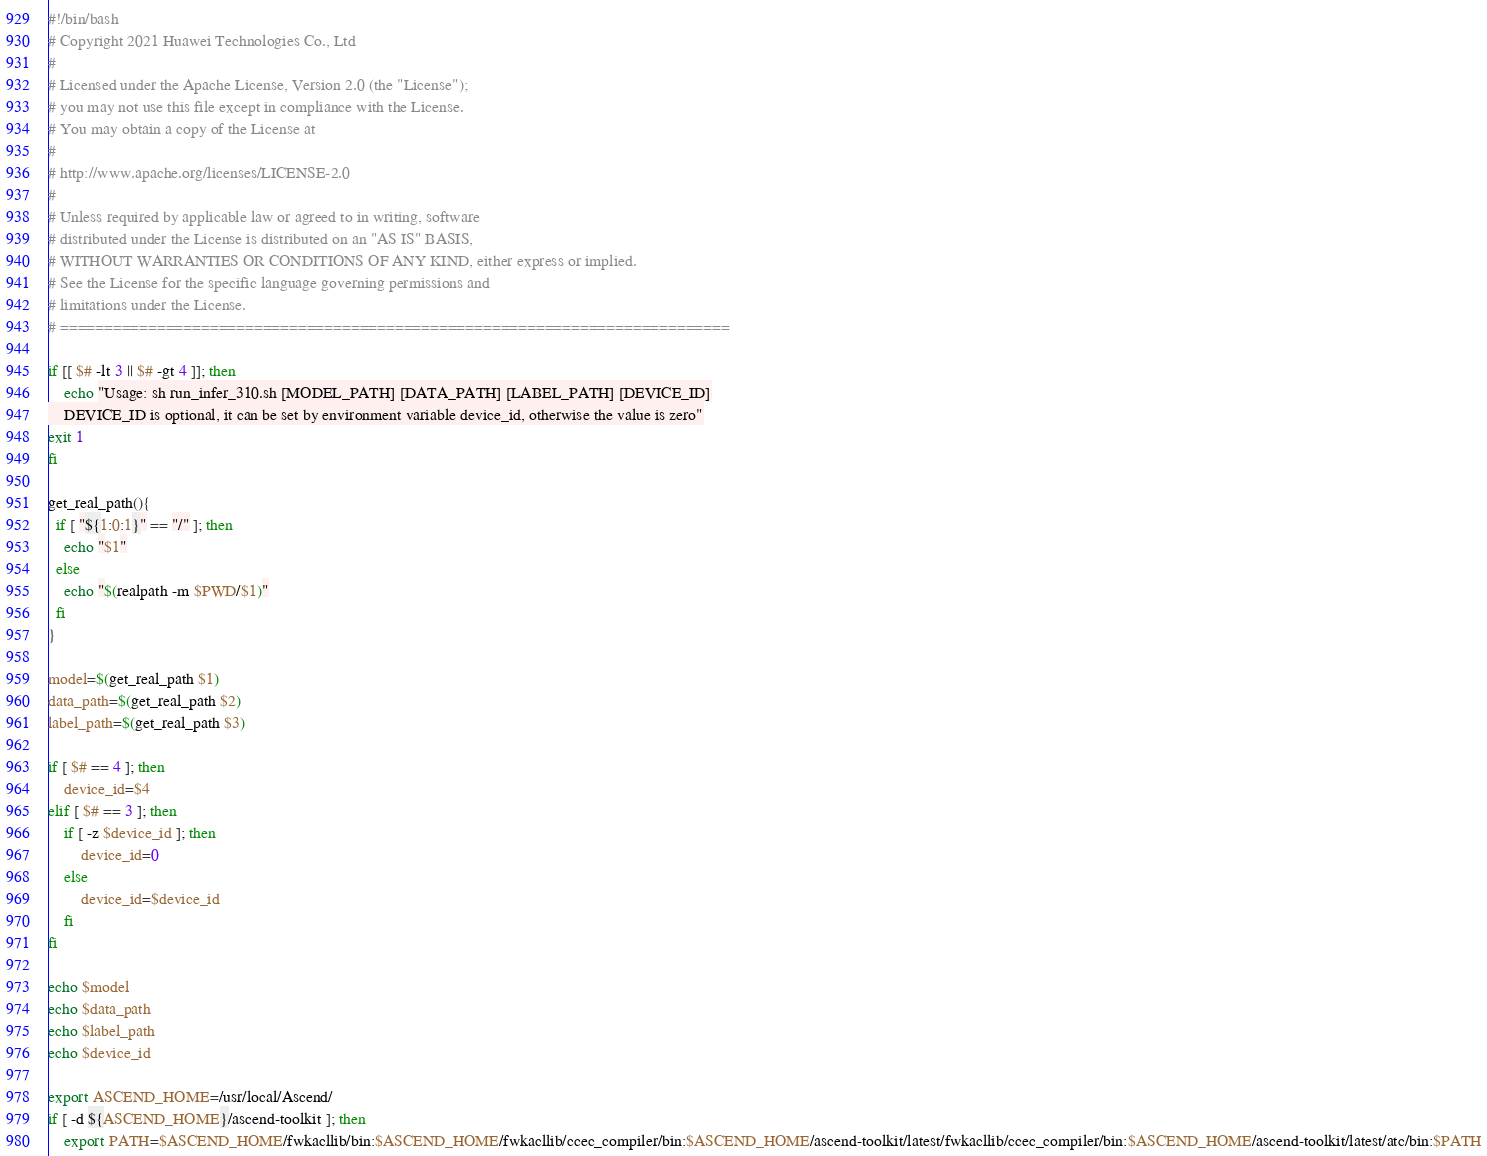Convert code to text. <code><loc_0><loc_0><loc_500><loc_500><_Bash_>#!/bin/bash
# Copyright 2021 Huawei Technologies Co., Ltd
#
# Licensed under the Apache License, Version 2.0 (the "License");
# you may not use this file except in compliance with the License.
# You may obtain a copy of the License at
#
# http://www.apache.org/licenses/LICENSE-2.0
#
# Unless required by applicable law or agreed to in writing, software
# distributed under the License is distributed on an "AS IS" BASIS,
# WITHOUT WARRANTIES OR CONDITIONS OF ANY KIND, either express or implied.
# See the License for the specific language governing permissions and
# limitations under the License.
# ============================================================================

if [[ $# -lt 3 || $# -gt 4 ]]; then 
    echo "Usage: sh run_infer_310.sh [MODEL_PATH] [DATA_PATH] [LABEL_PATH] [DEVICE_ID]
    DEVICE_ID is optional, it can be set by environment variable device_id, otherwise the value is zero"
exit 1
fi

get_real_path(){
  if [ "${1:0:1}" == "/" ]; then
    echo "$1"
  else
    echo "$(realpath -m $PWD/$1)"
  fi
}

model=$(get_real_path $1)
data_path=$(get_real_path $2)
label_path=$(get_real_path $3)

if [ $# == 4 ]; then
    device_id=$4
elif [ $# == 3 ]; then
    if [ -z $device_id ]; then
        device_id=0
    else
        device_id=$device_id
    fi
fi

echo $model
echo $data_path
echo $label_path
echo $device_id

export ASCEND_HOME=/usr/local/Ascend/
if [ -d ${ASCEND_HOME}/ascend-toolkit ]; then
    export PATH=$ASCEND_HOME/fwkacllib/bin:$ASCEND_HOME/fwkacllib/ccec_compiler/bin:$ASCEND_HOME/ascend-toolkit/latest/fwkacllib/ccec_compiler/bin:$ASCEND_HOME/ascend-toolkit/latest/atc/bin:$PATH</code> 